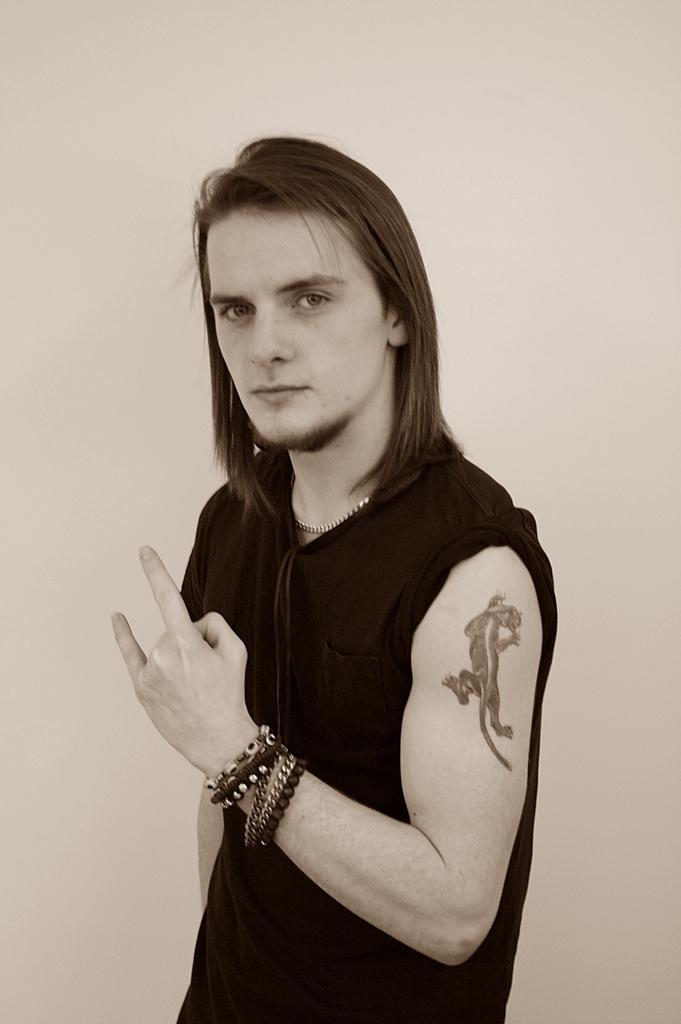In one or two sentences, can you explain what this image depicts? In this picture we can see a person and we can see a wall in the background. 